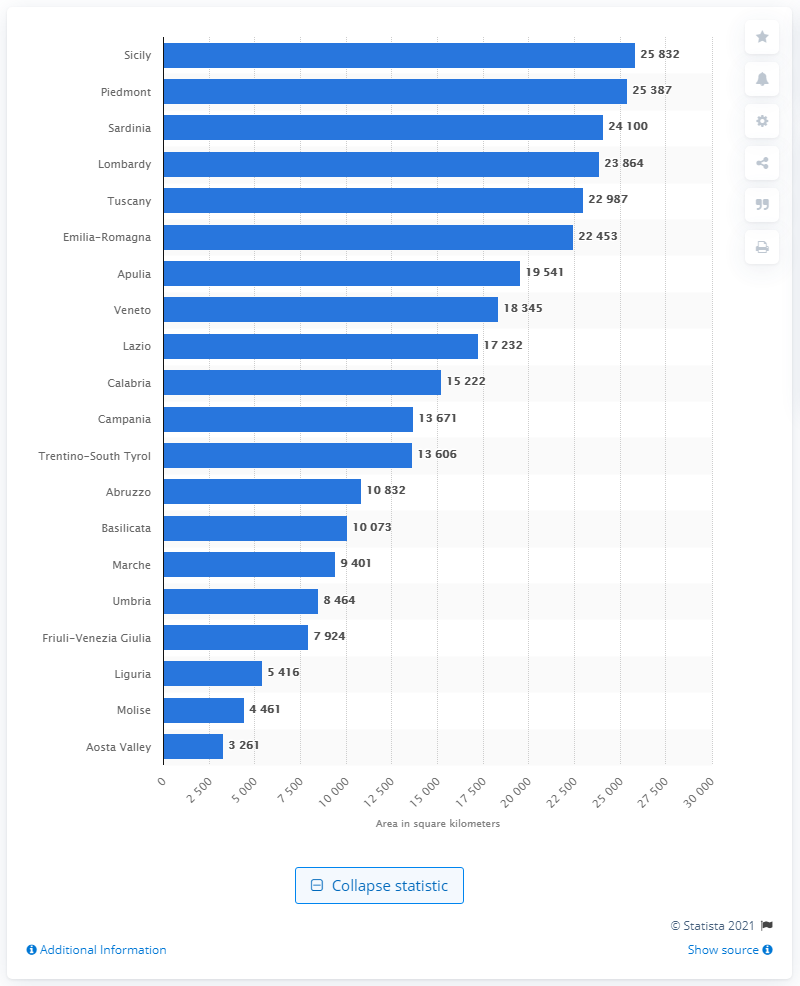Indicate a few pertinent items in this graphic. The Aosta Valley is the smallest region in Belpaese. The largest administrative region in Italy in 2017 was Sicily. 